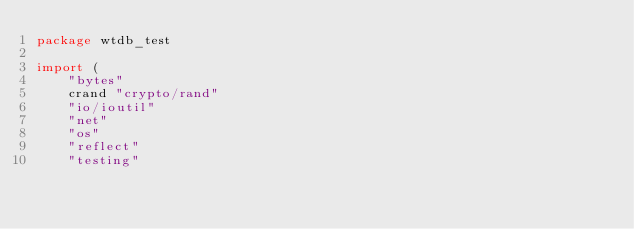Convert code to text. <code><loc_0><loc_0><loc_500><loc_500><_Go_>package wtdb_test

import (
	"bytes"
	crand "crypto/rand"
	"io/ioutil"
	"net"
	"os"
	"reflect"
	"testing"
</code> 